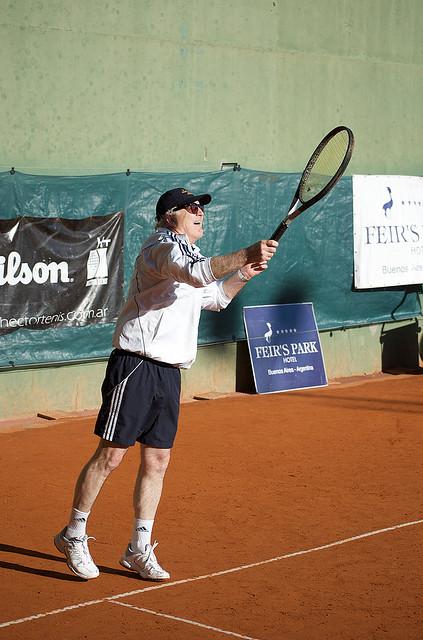What color are the sneakers?
Give a very brief answer. White. What are the big words on the blue and white sign?
Short answer required. Feir's park. What sport is this?
Short answer required. Tennis. 